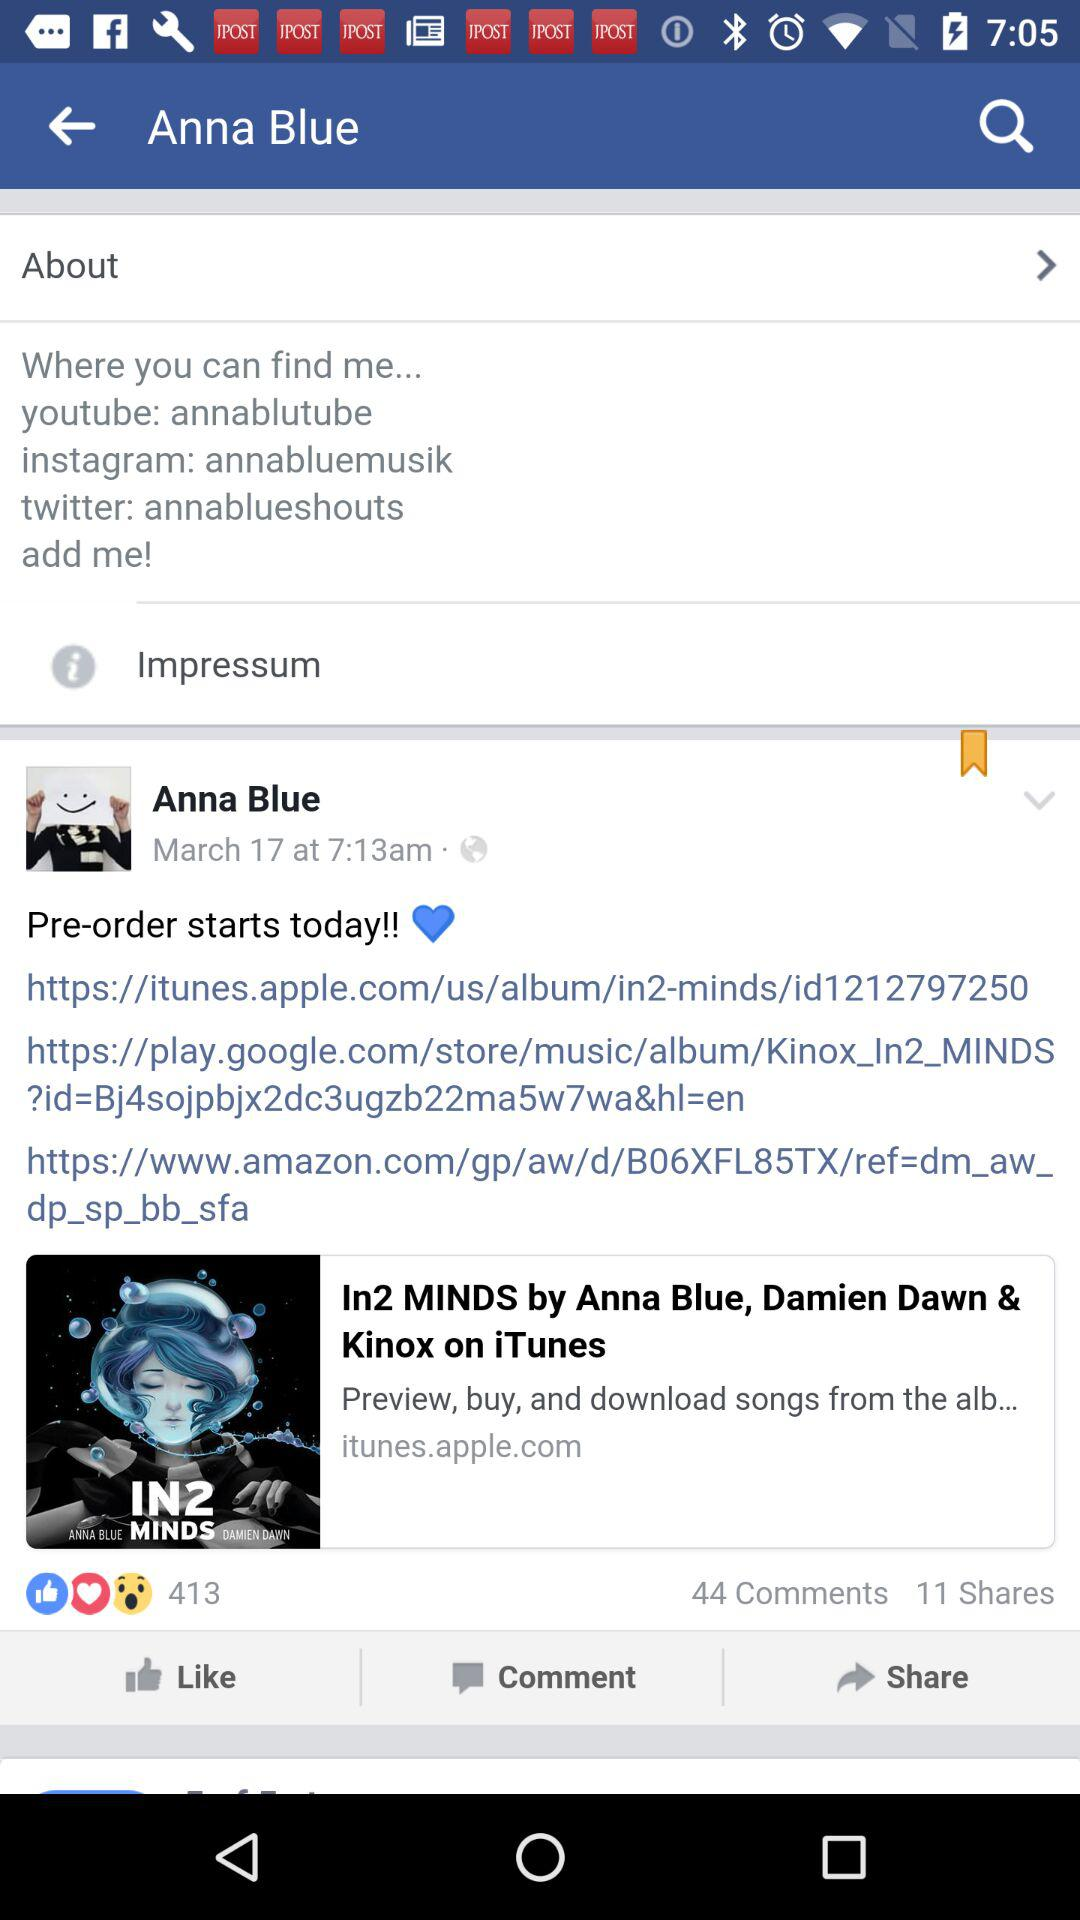What is the name of the profile? The name of the profile is Anna Blue. 